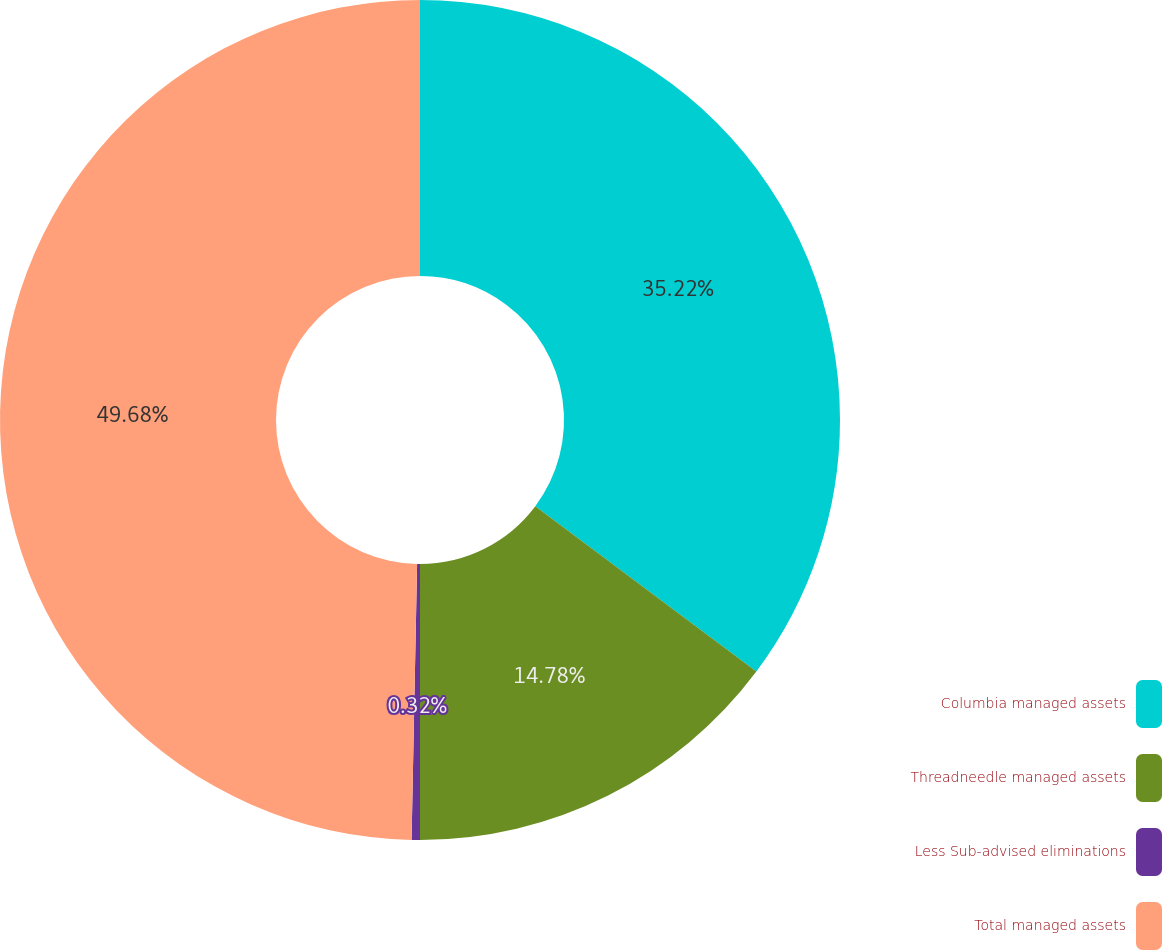<chart> <loc_0><loc_0><loc_500><loc_500><pie_chart><fcel>Columbia managed assets<fcel>Threadneedle managed assets<fcel>Less Sub-advised eliminations<fcel>Total managed assets<nl><fcel>35.22%<fcel>14.78%<fcel>0.32%<fcel>49.68%<nl></chart> 